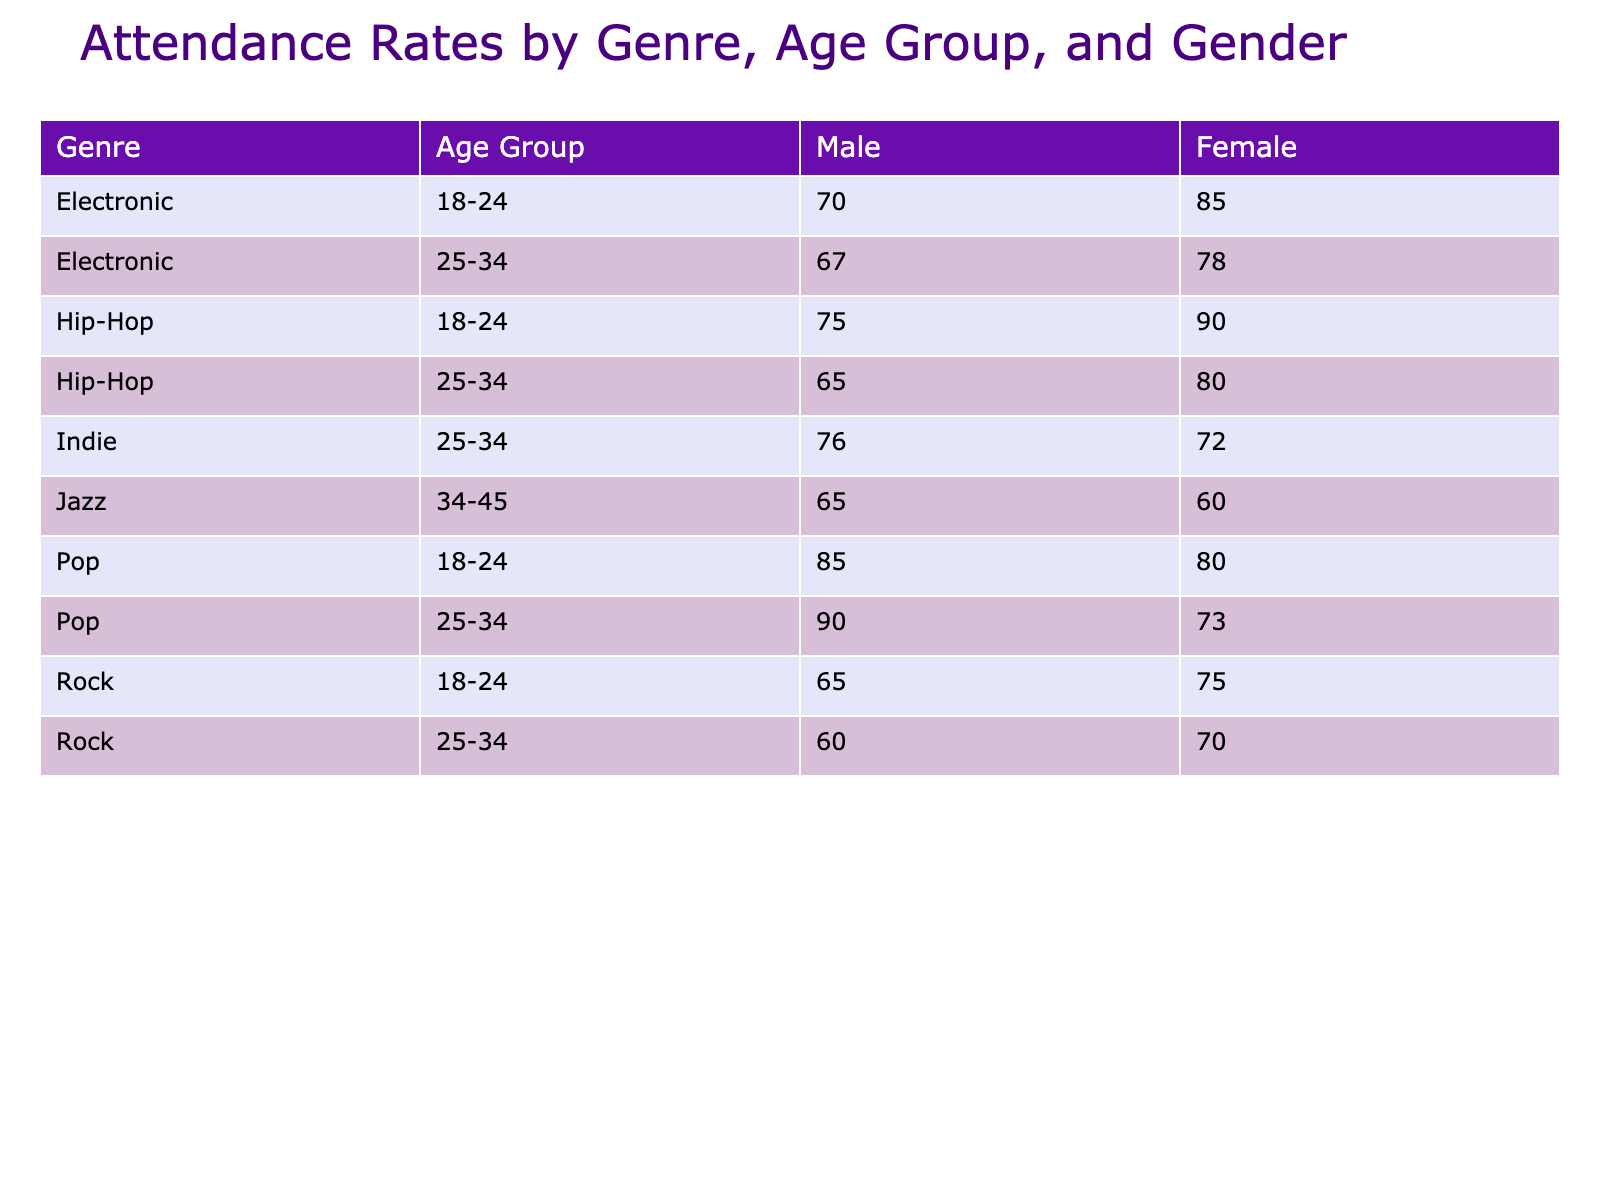What's the attendance rate for Female attendees in the Pop genre aged 25-34? Looking at the table, under the Pop genre and the age group of 25-34, the Female attendance rate is directly provided as 90%.
Answer: 90% Which genre has the highest attendance rate for Male attendees in the age group of 18-24? The table indicates that Hip-Hop has a male attendance rate of 90% for the age group of 18-24, which is higher than Rock at 75% and Pop at 80%.
Answer: Hip-Hop What is the average attendance rate for Female attendees across all genres in the age group of 25-34? First, I compile the attendance rates for Female attendees aged 25-34: Pop (90%), Hip-Hop (65%), Electronic (67%), and Indie (76%). Adding these values gives 90 + 65 + 67 + 76 = 298. There are 4 genres, so the average is 298 / 4 = 74.5%.
Answer: 74.5% Is the attendance rate for Male attendees in the Indie genre higher than that in the Jazz genre for the age group of 34-45? In the table, the rate for Male attendees in the Indie genre is 72%, while the rate for Male attendees in the Jazz genre is 60%. Since 72% is greater than 60%, the statement is true.
Answer: Yes Calculate the difference in attendance rates between the highest and lowest for Female attendees in the age group of 18-24. Reviewing the table, for Female attendees aged 18-24, Pop has the highest rate at 85% and Hip-Hop has the lowest at 75%. The difference is 85% - 75% = 10%.
Answer: 10% Does the Electronic genre have a higher average attendance rate for attendees aged 18-24 compared to Rock? The attendance rates for Electronic attendees aged 18-24 is 85% (Male) and 70% (Female), giving an average of (85 + 70) / 2 = 77.5%. For Rock, it is (75 + 65) / 2 = 70%. Since 77.5% is greater than 70%, the statement is true.
Answer: Yes What is the attendance rate for Female attendees in Rock aged 25-34 compared to that of Male attendees in the same age group? In the table, the attendance rate for Female attendees in Rock aged 25-34 is 60%, while for Male attendees it is 70%. Comparing these two rates, 70% (Male) is higher than 60% (Female).
Answer: 60% vs 70% What is the total attendance count for the Jazz genre for both genders in the age group of 34-45? The table shows that the event counts for Jazz are 8 for both Male and Female attendees. Therefore, the total attendance count is 8 (Male) + 8 (Female) = 16.
Answer: 16 Which gender has a higher attendance rate in the Electronic genre for the age group 25-34? In the table, for Electronic attendees aged 25-34, Male attendees have an attendance rate of 78% and Female attendees have a rate of 67%. Therefore, Male attendees have the higher attendance rate.
Answer: Male 